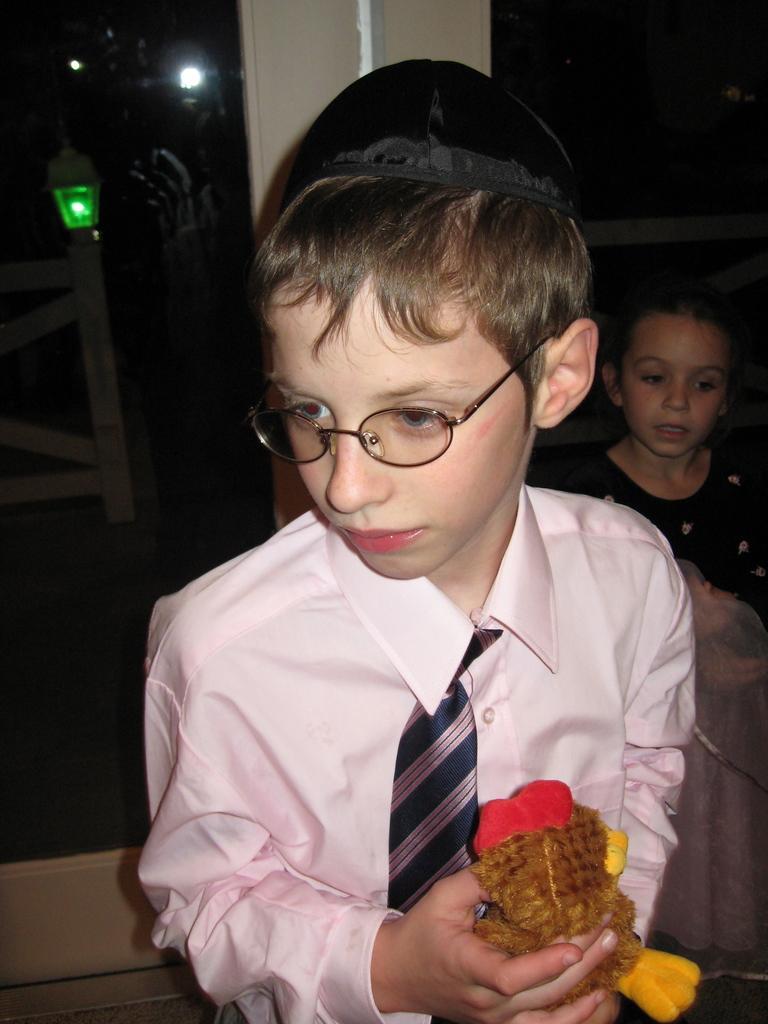Please provide a concise description of this image. In the middle of this image, there is a person in a pink color shirt, wearing a spectacle and a cap and holding a doll. In the background, there is a girl and there are two glass doors. Through this glass door, we can see there are lights and a fence. 